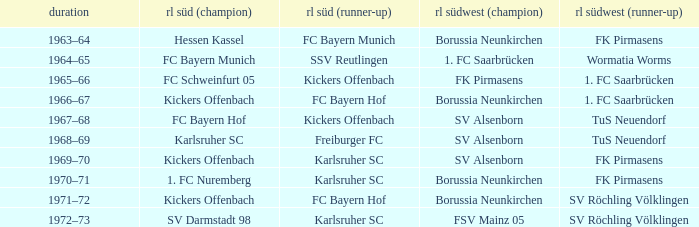Who was RL Süd (1st) when FK Pirmasens was RL Südwest (1st)? FC Schweinfurt 05. 